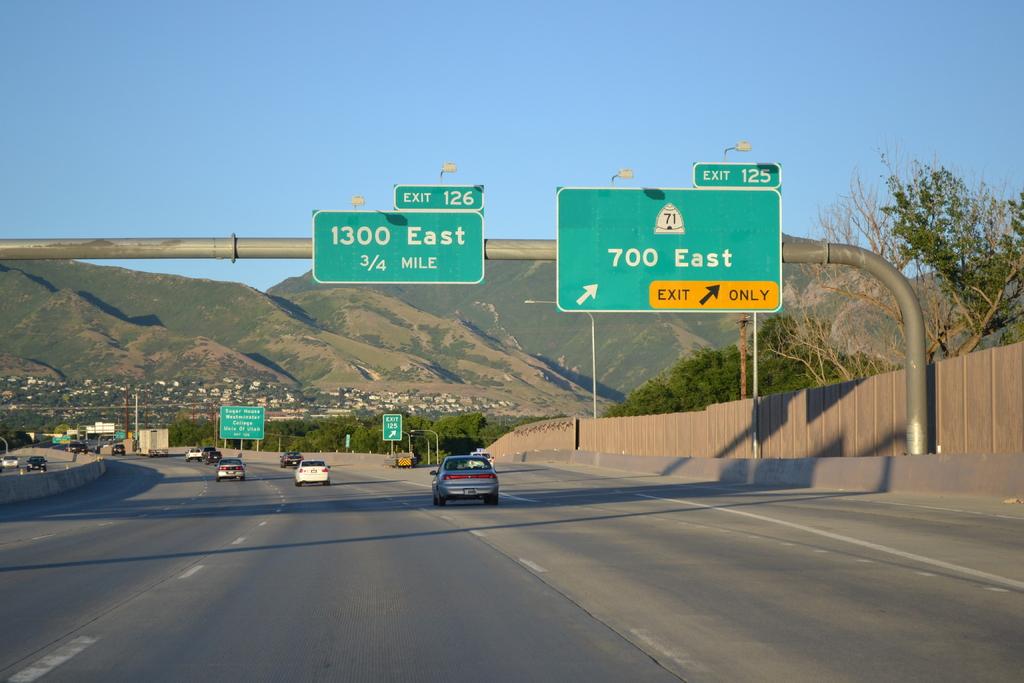How far to 1300 east?
Provide a succinct answer. 3/4 mile. Which exit number leads to 1300 east?
Your answer should be very brief. 126. 